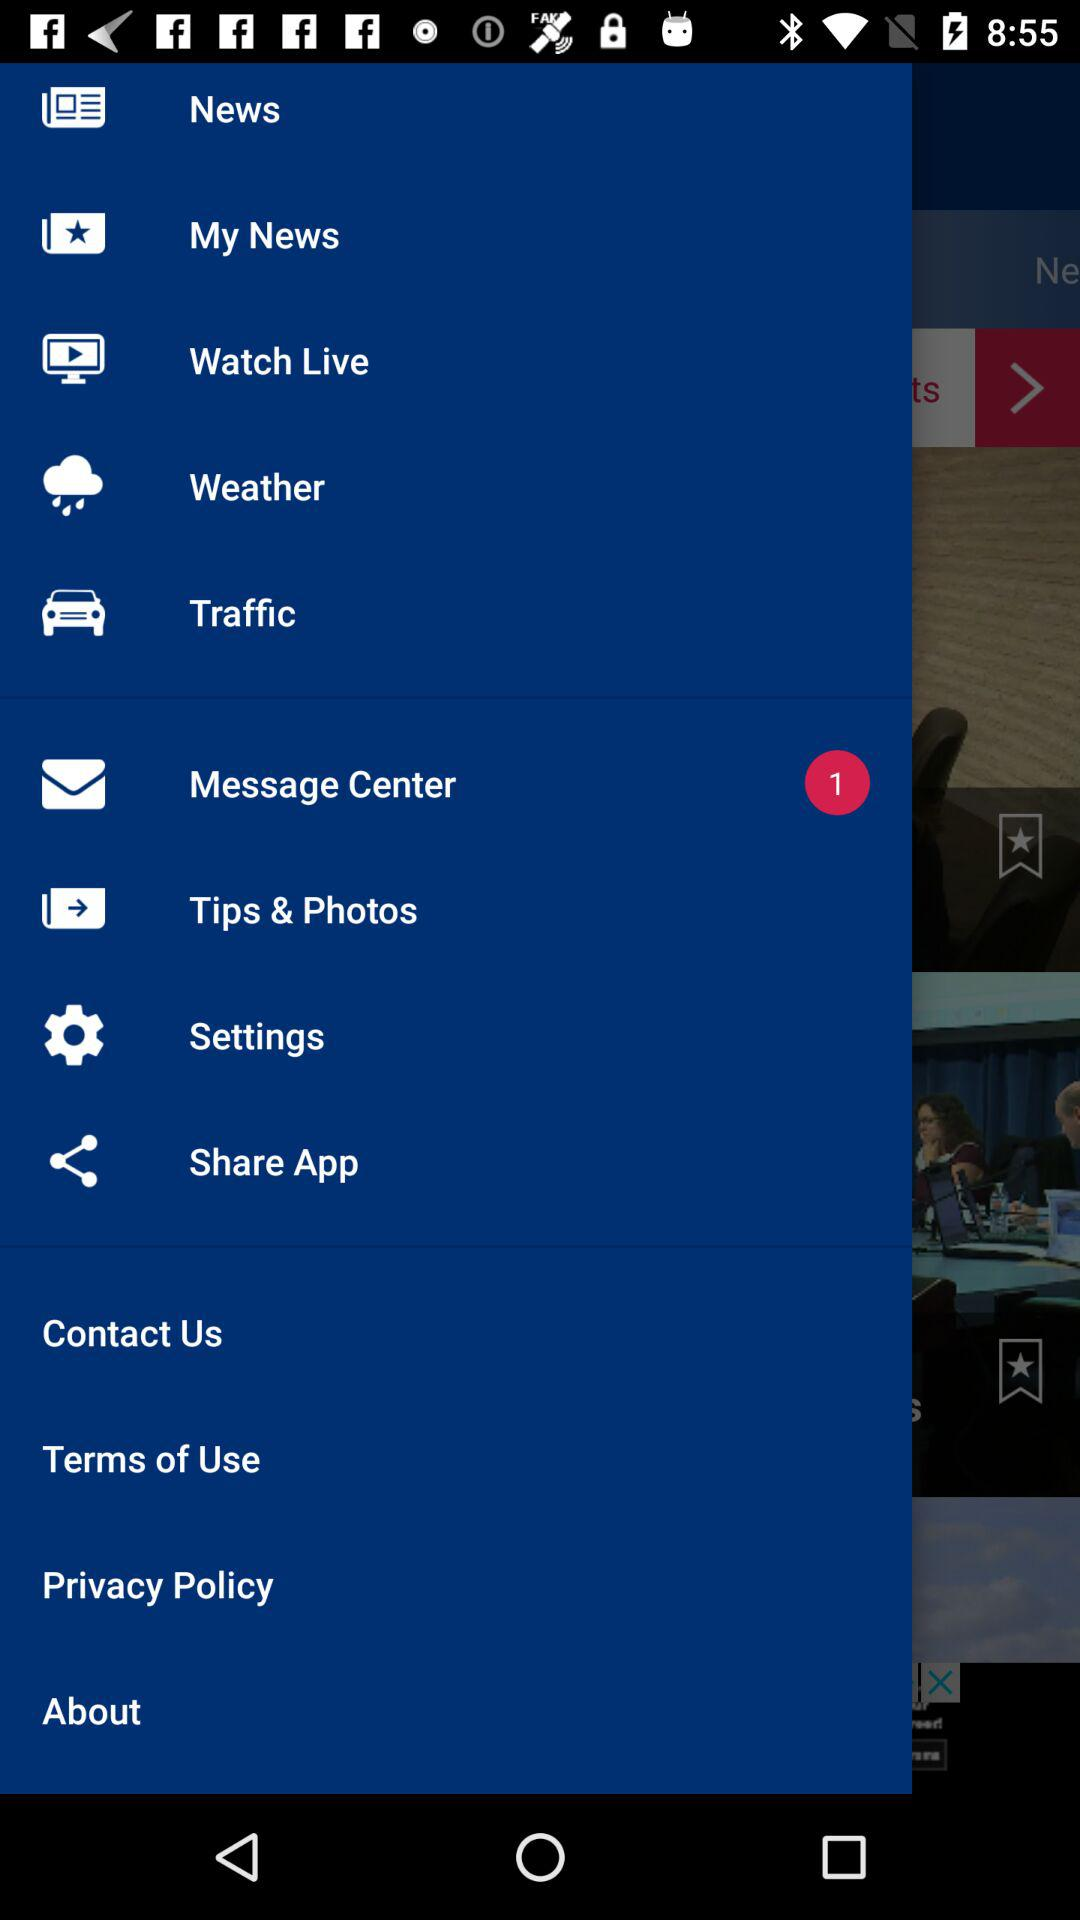How many unread messages are there in "Message Center"? There is 1 unread message in "Message Center". 